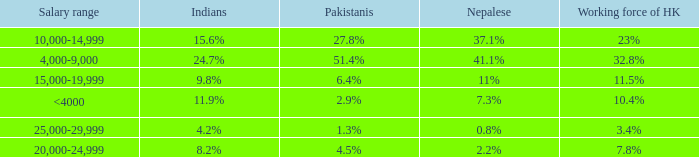If the nepalese is 37.1%, what is the working force of HK? 23%. 